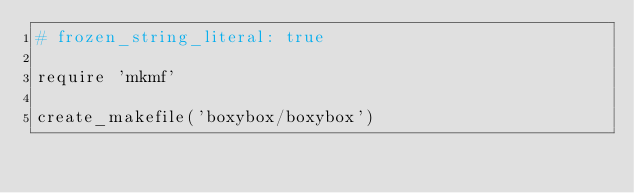<code> <loc_0><loc_0><loc_500><loc_500><_Ruby_># frozen_string_literal: true

require 'mkmf'

create_makefile('boxybox/boxybox')
</code> 